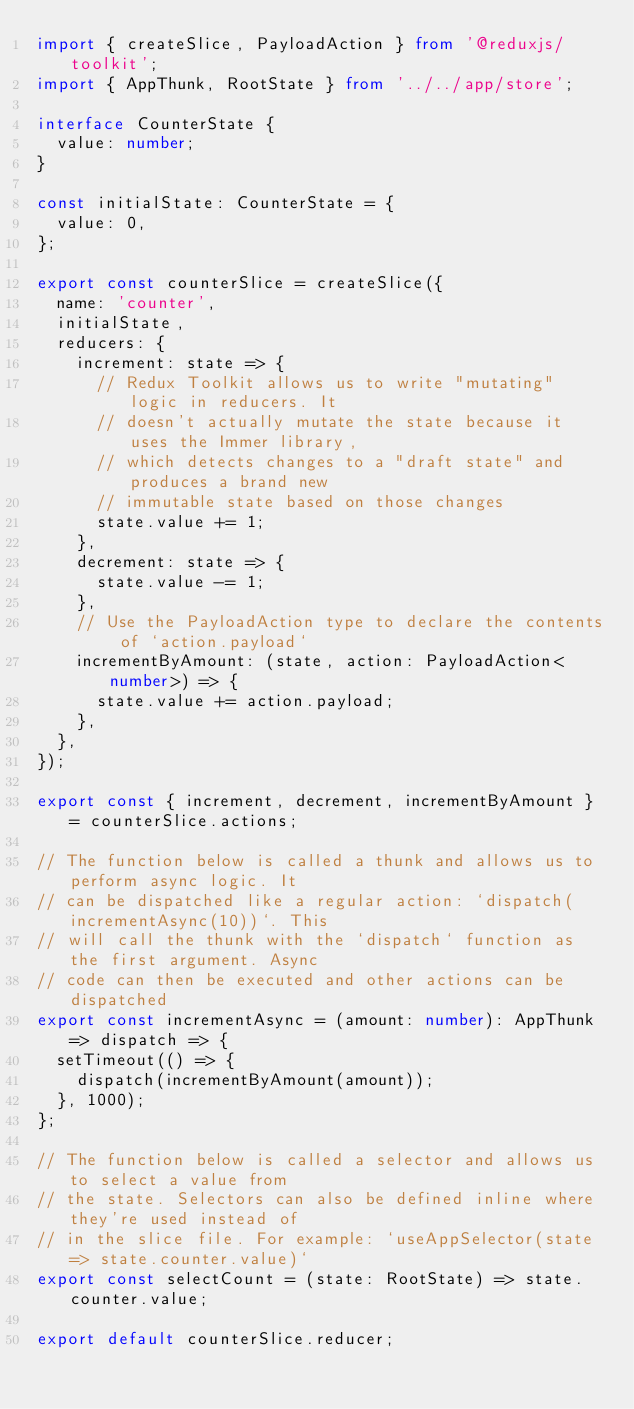<code> <loc_0><loc_0><loc_500><loc_500><_TypeScript_>import { createSlice, PayloadAction } from '@reduxjs/toolkit';
import { AppThunk, RootState } from '../../app/store';

interface CounterState {
  value: number;
}

const initialState: CounterState = {
  value: 0,
};

export const counterSlice = createSlice({
  name: 'counter',
  initialState,
  reducers: {
    increment: state => {
      // Redux Toolkit allows us to write "mutating" logic in reducers. It
      // doesn't actually mutate the state because it uses the Immer library,
      // which detects changes to a "draft state" and produces a brand new
      // immutable state based on those changes
      state.value += 1;
    },
    decrement: state => {
      state.value -= 1;
    },
    // Use the PayloadAction type to declare the contents of `action.payload`
    incrementByAmount: (state, action: PayloadAction<number>) => {
      state.value += action.payload;
    },
  },
});

export const { increment, decrement, incrementByAmount } = counterSlice.actions;

// The function below is called a thunk and allows us to perform async logic. It
// can be dispatched like a regular action: `dispatch(incrementAsync(10))`. This
// will call the thunk with the `dispatch` function as the first argument. Async
// code can then be executed and other actions can be dispatched
export const incrementAsync = (amount: number): AppThunk => dispatch => {
  setTimeout(() => {
    dispatch(incrementByAmount(amount));
  }, 1000);
};

// The function below is called a selector and allows us to select a value from
// the state. Selectors can also be defined inline where they're used instead of
// in the slice file. For example: `useAppSelector(state => state.counter.value)`
export const selectCount = (state: RootState) => state.counter.value;

export default counterSlice.reducer;
</code> 